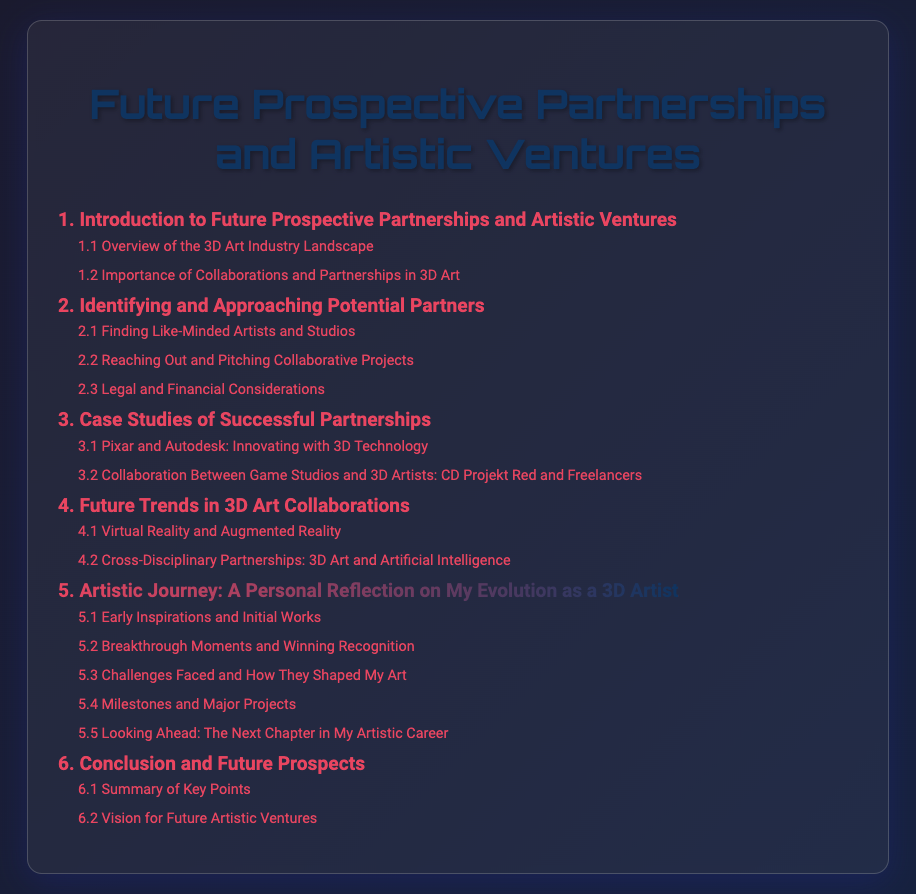what is the title of the document? The title of the document, as indicated at the top, is "Future Prospective Partnerships and Artistic Ventures."
Answer: Future Prospective Partnerships and Artistic Ventures how many main sections are there in the table of contents? There are a total of 6 main sections listed in the table of contents.
Answer: 6 what is the highlight section in the table of contents? The highlighted section in the table of contents focuses on the personal artistic journey of the author.
Answer: Artistic Journey: A Personal Reflection on My Evolution as a 3D Artist which subsection discusses challenges faced by the artist? The subsection that addresses challenges faced by the artist is labeled as "5.3 Challenges Faced and How They Shaped My Art."
Answer: 5.3 Challenges Faced and How They Shaped My Art what is the first subsection under the fifth main section? The first subsection outlined under the fifth main section details the artist's early inspirations.
Answer: 5.1 Early Inspirations and Initial Works which section includes future trends in 3D art collaborations? Future trends in 3D art collaborations are covered in section four of the document.
Answer: 4. Future Trends in 3D Art Collaborations who are the collaborators mentioned in the case study? The case study mentions "Pixar" and "Autodesk" as collaborators in the context of innovating with 3D technology.
Answer: Pixar and Autodesk 